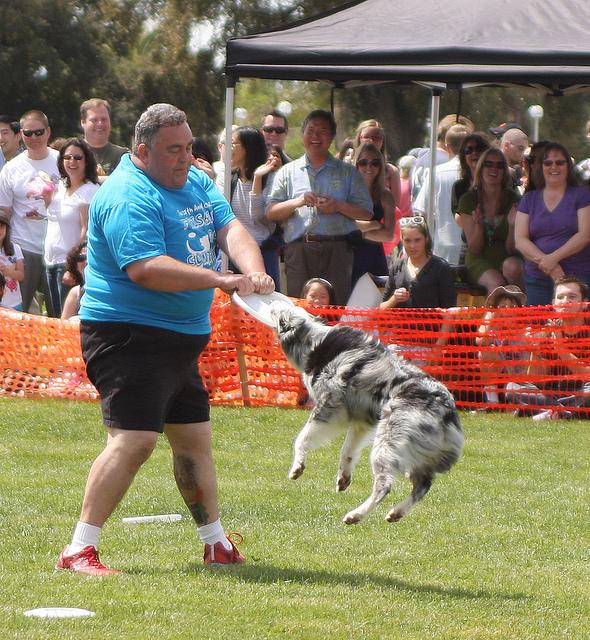What is the man wearing?
Give a very brief answer. Blue shirt, black shorts. What kind of dog?
Write a very short answer. Shepard. Is the dog attacking the man?
Answer briefly. No. What is this dog known for?
Keep it brief. Frisbee. Is the man holding the frisbee with one hand?
Short answer required. No. 